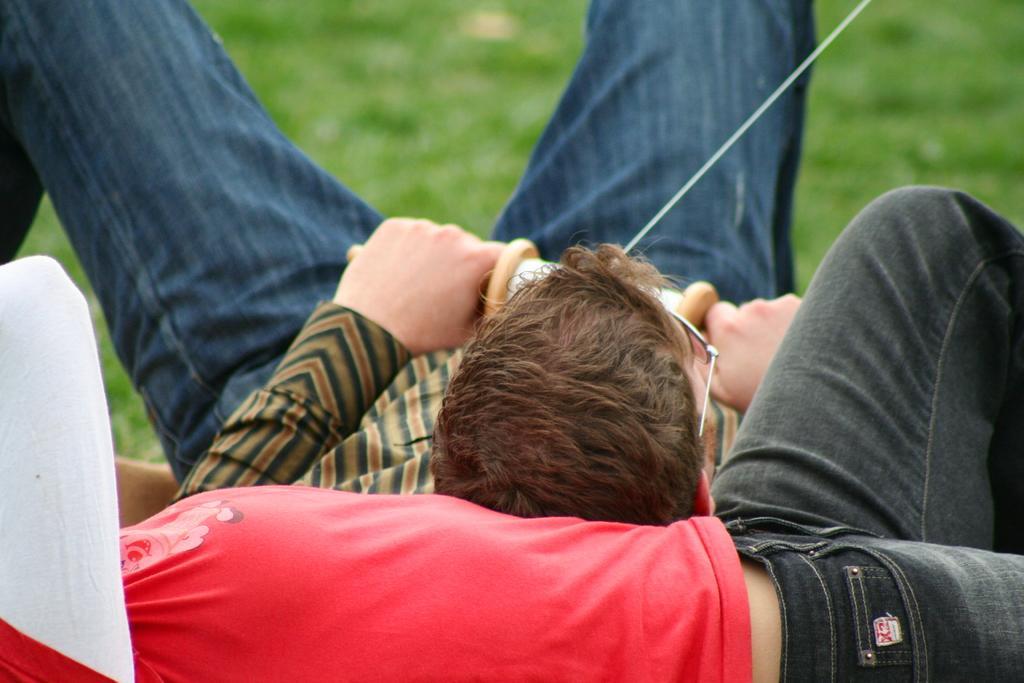Could you give a brief overview of what you see in this image? In this picture there are two people lying. In the center of the picture the person is holding a wooden object and there is threat to it. At the top there is grass. 